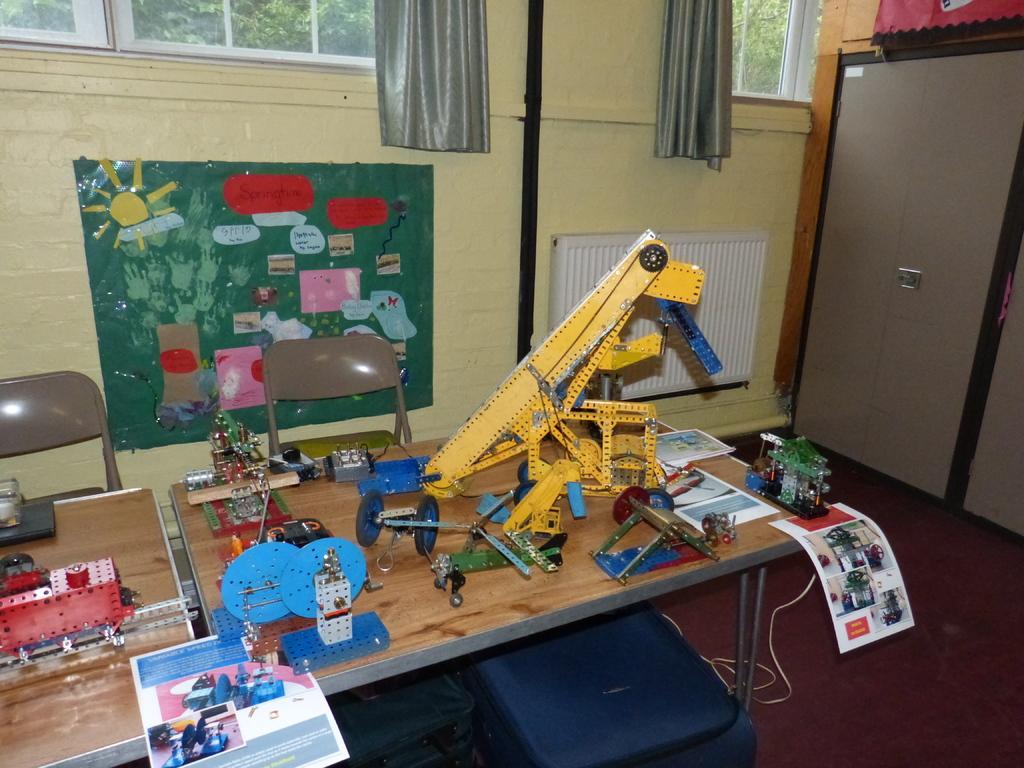Can you describe this image briefly? In this picture there is a table on which some of the toys and some photographs were placed on the table. Behind the table there are some chairs and some charts were stick to the wall. There is a cupboard in the right side. In the background there are some curtains, windows and trees. 